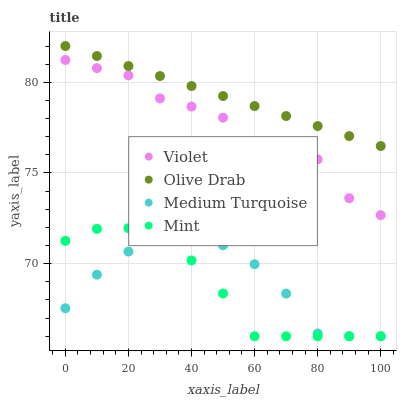Does Mint have the minimum area under the curve?
Answer yes or no. Yes. Does Olive Drab have the maximum area under the curve?
Answer yes or no. Yes. Does Medium Turquoise have the minimum area under the curve?
Answer yes or no. No. Does Medium Turquoise have the maximum area under the curve?
Answer yes or no. No. Is Olive Drab the smoothest?
Answer yes or no. Yes. Is Violet the roughest?
Answer yes or no. Yes. Is Medium Turquoise the smoothest?
Answer yes or no. No. Is Medium Turquoise the roughest?
Answer yes or no. No. Does Mint have the lowest value?
Answer yes or no. Yes. Does Olive Drab have the lowest value?
Answer yes or no. No. Does Olive Drab have the highest value?
Answer yes or no. Yes. Does Medium Turquoise have the highest value?
Answer yes or no. No. Is Medium Turquoise less than Violet?
Answer yes or no. Yes. Is Olive Drab greater than Mint?
Answer yes or no. Yes. Does Mint intersect Medium Turquoise?
Answer yes or no. Yes. Is Mint less than Medium Turquoise?
Answer yes or no. No. Is Mint greater than Medium Turquoise?
Answer yes or no. No. Does Medium Turquoise intersect Violet?
Answer yes or no. No. 